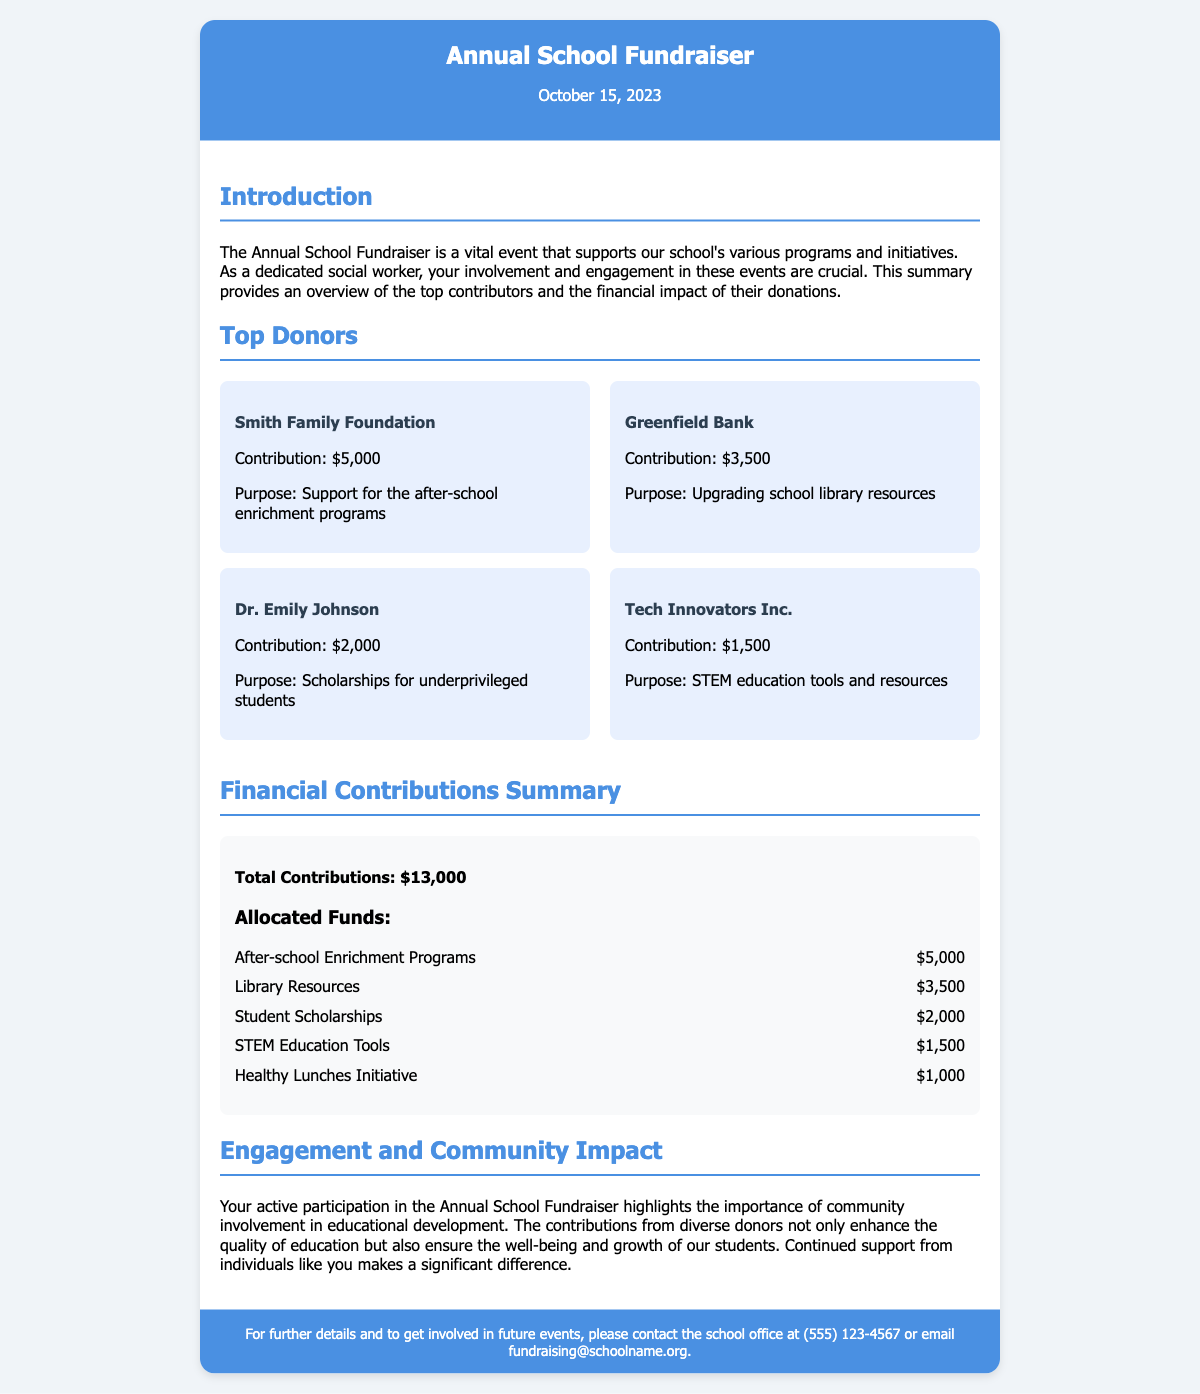What is the date of the fundraiser? The date of the fundraiser is mentioned at the top of the document as October 15, 2023.
Answer: October 15, 2023 Who made a contribution of $5,000? The document lists the Smith Family Foundation as the donor who contributed $5,000.
Answer: Smith Family Foundation What is the total amount of contributions? The total contributions are clearly stated in the financial summary section as $13,000.
Answer: $13,000 How much money is allocated to the After-school Enrichment Programs? The document specifies that $5,000 is allocated for After-school Enrichment Programs in the financial contributions summary.
Answer: $5,000 Which donor supported the STEM education tools and resources? Tech Innovators Inc. is identified as the donor who contributed $1,500 for STEM education tools and resources.
Answer: Tech Innovators Inc What is the purpose of Dr. Emily Johnson's contribution? The purpose of Dr. Emily Johnson's contribution of $2,000 is to provide scholarships for underprivileged students.
Answer: Scholarships for underprivileged students What percentage of the total contributions is allocated to the Library Resources? Library Resources received $3,500, which is approximately 26.92% of the total contributions of $13,000.
Answer: 26.92% How many donors are listed in the document? There are four donors listed in the top donors section of the document.
Answer: Four What email can be used to contact the school for further details? The document provides the email address fundraising@schoolname.org for further inquiries.
Answer: fundraising@schoolname.org 